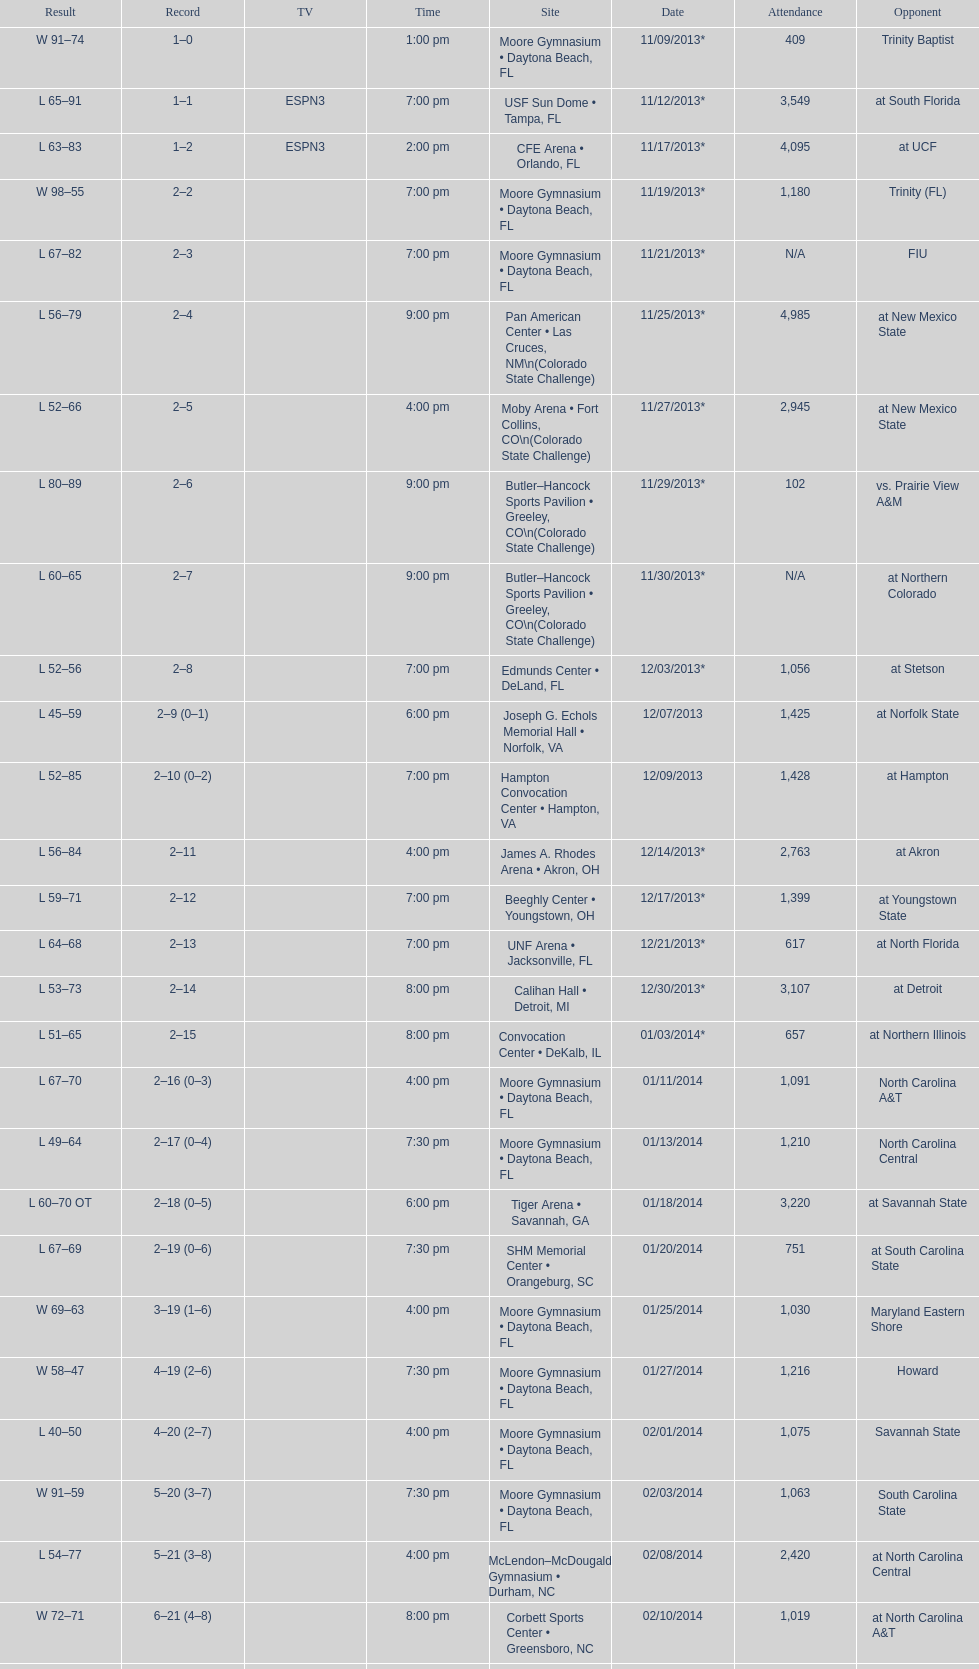What is the total attendance on 11/09/2013? 409. 